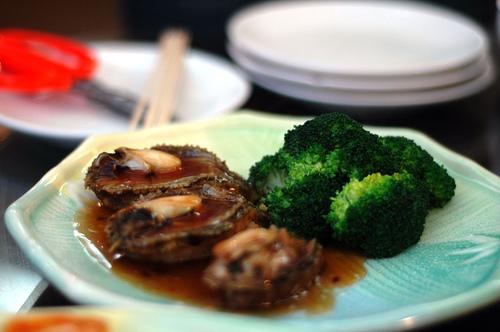What green vegetable is shown?
Quick response, please. Broccoli. What type of food is in this picture?
Short answer required. Broccoli, pork. Is this a healthy meal?
Answer briefly. Yes. What is green in this picture?
Keep it brief. Broccoli. How many plates are pictured?
Give a very brief answer. 5. 